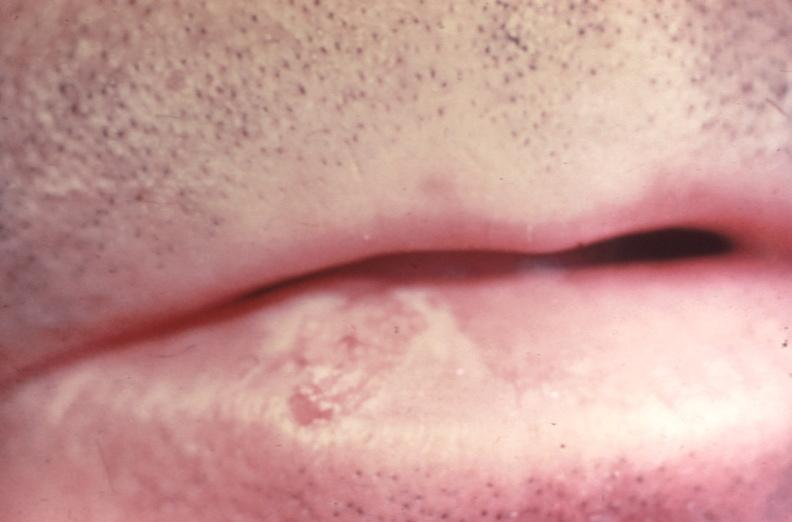s gastrointestinal present?
Answer the question using a single word or phrase. Yes 